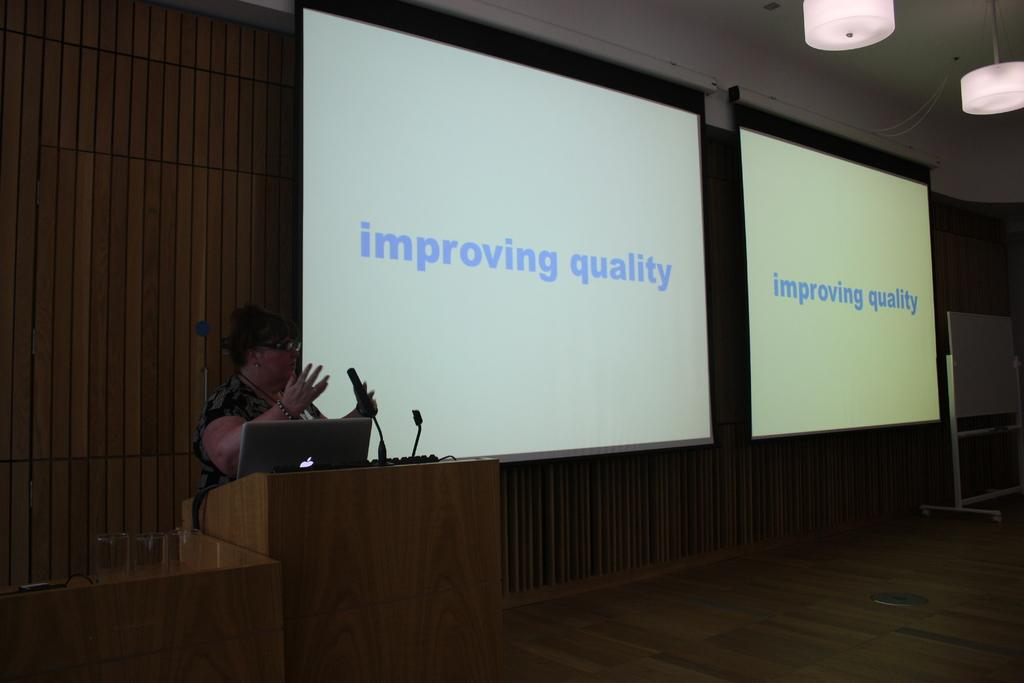Who is the main subject in the image? There is a woman in the image. What is the woman doing in the image? The woman is standing in front of a microphone. What electronic device is present in the image? There is a laptop in the image. What can be seen on the board in the image? There is a display visible on the board. How many toes can be seen on the woman's feet in the image? There is no visible indication of the woman's feet or toes in the image. 